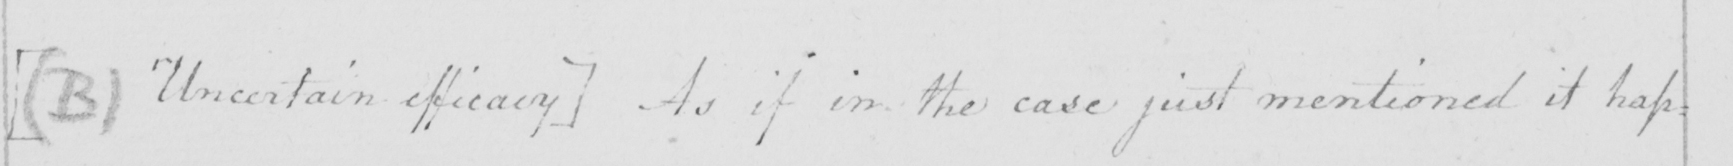Please provide the text content of this handwritten line. [(B) Uncertain efficacy] As if in the case just mentioned it hap= 